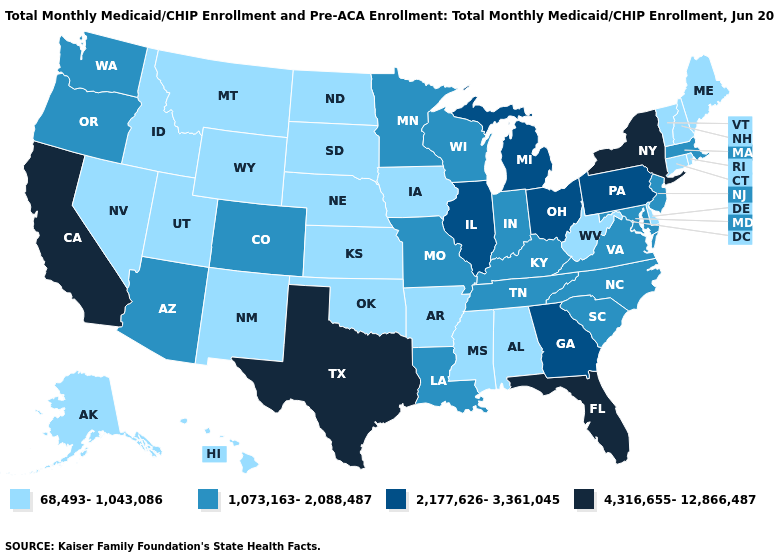What is the lowest value in the USA?
Short answer required. 68,493-1,043,086. Among the states that border Georgia , which have the highest value?
Write a very short answer. Florida. Among the states that border Louisiana , which have the lowest value?
Concise answer only. Arkansas, Mississippi. Name the states that have a value in the range 2,177,626-3,361,045?
Keep it brief. Georgia, Illinois, Michigan, Ohio, Pennsylvania. What is the highest value in the USA?
Answer briefly. 4,316,655-12,866,487. What is the value of Missouri?
Concise answer only. 1,073,163-2,088,487. What is the value of New York?
Give a very brief answer. 4,316,655-12,866,487. Does Maryland have a lower value than New York?
Answer briefly. Yes. Among the states that border Arizona , which have the lowest value?
Quick response, please. Nevada, New Mexico, Utah. Does the first symbol in the legend represent the smallest category?
Short answer required. Yes. Among the states that border Florida , which have the lowest value?
Give a very brief answer. Alabama. Which states have the lowest value in the USA?
Write a very short answer. Alabama, Alaska, Arkansas, Connecticut, Delaware, Hawaii, Idaho, Iowa, Kansas, Maine, Mississippi, Montana, Nebraska, Nevada, New Hampshire, New Mexico, North Dakota, Oklahoma, Rhode Island, South Dakota, Utah, Vermont, West Virginia, Wyoming. Name the states that have a value in the range 1,073,163-2,088,487?
Keep it brief. Arizona, Colorado, Indiana, Kentucky, Louisiana, Maryland, Massachusetts, Minnesota, Missouri, New Jersey, North Carolina, Oregon, South Carolina, Tennessee, Virginia, Washington, Wisconsin. What is the lowest value in the MidWest?
Be succinct. 68,493-1,043,086. What is the value of Nevada?
Give a very brief answer. 68,493-1,043,086. 